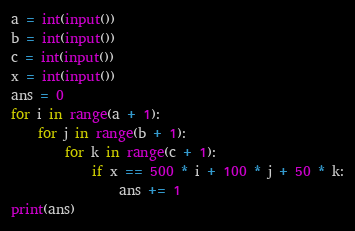<code> <loc_0><loc_0><loc_500><loc_500><_Python_>a = int(input())
b = int(input())
c = int(input())
x = int(input())
ans = 0
for i in range(a + 1):
    for j in range(b + 1):
        for k in range(c + 1):
            if x == 500 * i + 100 * j + 50 * k:
                ans += 1
print(ans)
</code> 